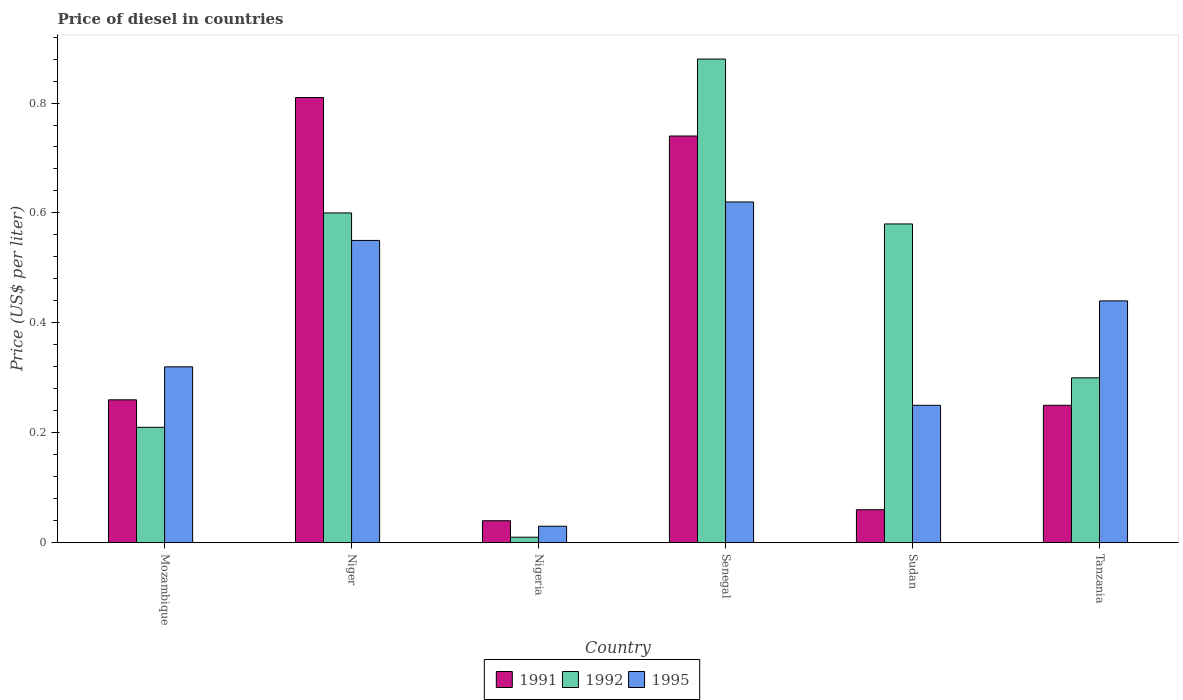How many different coloured bars are there?
Provide a succinct answer. 3. How many groups of bars are there?
Your response must be concise. 6. How many bars are there on the 5th tick from the left?
Make the answer very short. 3. How many bars are there on the 6th tick from the right?
Your answer should be very brief. 3. What is the label of the 6th group of bars from the left?
Your answer should be compact. Tanzania. What is the price of diesel in 1992 in Nigeria?
Provide a short and direct response. 0.01. Across all countries, what is the maximum price of diesel in 1991?
Your answer should be compact. 0.81. In which country was the price of diesel in 1991 maximum?
Ensure brevity in your answer.  Niger. In which country was the price of diesel in 1991 minimum?
Provide a short and direct response. Nigeria. What is the total price of diesel in 1991 in the graph?
Your answer should be very brief. 2.16. What is the difference between the price of diesel in 1992 in Mozambique and that in Niger?
Your response must be concise. -0.39. What is the difference between the price of diesel in 1995 in Tanzania and the price of diesel in 1991 in Sudan?
Offer a very short reply. 0.38. What is the average price of diesel in 1995 per country?
Offer a terse response. 0.37. What is the difference between the price of diesel of/in 1992 and price of diesel of/in 1995 in Niger?
Make the answer very short. 0.05. Is the price of diesel in 1995 in Mozambique less than that in Nigeria?
Your response must be concise. No. What is the difference between the highest and the second highest price of diesel in 1991?
Ensure brevity in your answer.  0.07. What is the difference between the highest and the lowest price of diesel in 1991?
Your response must be concise. 0.77. In how many countries, is the price of diesel in 1995 greater than the average price of diesel in 1995 taken over all countries?
Provide a succinct answer. 3. Is the sum of the price of diesel in 1992 in Mozambique and Senegal greater than the maximum price of diesel in 1991 across all countries?
Your response must be concise. Yes. What does the 1st bar from the left in Sudan represents?
Provide a short and direct response. 1991. How many countries are there in the graph?
Offer a terse response. 6. What is the difference between two consecutive major ticks on the Y-axis?
Keep it short and to the point. 0.2. Does the graph contain any zero values?
Your answer should be compact. No. Does the graph contain grids?
Ensure brevity in your answer.  No. What is the title of the graph?
Provide a short and direct response. Price of diesel in countries. Does "1982" appear as one of the legend labels in the graph?
Give a very brief answer. No. What is the label or title of the Y-axis?
Offer a terse response. Price (US$ per liter). What is the Price (US$ per liter) in 1991 in Mozambique?
Offer a very short reply. 0.26. What is the Price (US$ per liter) of 1992 in Mozambique?
Provide a succinct answer. 0.21. What is the Price (US$ per liter) in 1995 in Mozambique?
Offer a very short reply. 0.32. What is the Price (US$ per liter) of 1991 in Niger?
Your answer should be very brief. 0.81. What is the Price (US$ per liter) of 1995 in Niger?
Provide a succinct answer. 0.55. What is the Price (US$ per liter) of 1991 in Nigeria?
Keep it short and to the point. 0.04. What is the Price (US$ per liter) in 1992 in Nigeria?
Ensure brevity in your answer.  0.01. What is the Price (US$ per liter) in 1995 in Nigeria?
Keep it short and to the point. 0.03. What is the Price (US$ per liter) in 1991 in Senegal?
Make the answer very short. 0.74. What is the Price (US$ per liter) in 1995 in Senegal?
Offer a very short reply. 0.62. What is the Price (US$ per liter) of 1991 in Sudan?
Offer a terse response. 0.06. What is the Price (US$ per liter) of 1992 in Sudan?
Ensure brevity in your answer.  0.58. What is the Price (US$ per liter) in 1995 in Tanzania?
Provide a short and direct response. 0.44. Across all countries, what is the maximum Price (US$ per liter) in 1991?
Offer a terse response. 0.81. Across all countries, what is the maximum Price (US$ per liter) of 1992?
Your response must be concise. 0.88. Across all countries, what is the maximum Price (US$ per liter) of 1995?
Your response must be concise. 0.62. Across all countries, what is the minimum Price (US$ per liter) of 1992?
Provide a succinct answer. 0.01. What is the total Price (US$ per liter) of 1991 in the graph?
Your answer should be very brief. 2.16. What is the total Price (US$ per liter) in 1992 in the graph?
Your answer should be compact. 2.58. What is the total Price (US$ per liter) in 1995 in the graph?
Offer a very short reply. 2.21. What is the difference between the Price (US$ per liter) in 1991 in Mozambique and that in Niger?
Your response must be concise. -0.55. What is the difference between the Price (US$ per liter) in 1992 in Mozambique and that in Niger?
Provide a succinct answer. -0.39. What is the difference between the Price (US$ per liter) in 1995 in Mozambique and that in Niger?
Your answer should be compact. -0.23. What is the difference between the Price (US$ per liter) in 1991 in Mozambique and that in Nigeria?
Provide a short and direct response. 0.22. What is the difference between the Price (US$ per liter) of 1992 in Mozambique and that in Nigeria?
Provide a short and direct response. 0.2. What is the difference between the Price (US$ per liter) in 1995 in Mozambique and that in Nigeria?
Your answer should be very brief. 0.29. What is the difference between the Price (US$ per liter) in 1991 in Mozambique and that in Senegal?
Provide a short and direct response. -0.48. What is the difference between the Price (US$ per liter) of 1992 in Mozambique and that in Senegal?
Ensure brevity in your answer.  -0.67. What is the difference between the Price (US$ per liter) of 1995 in Mozambique and that in Senegal?
Your answer should be compact. -0.3. What is the difference between the Price (US$ per liter) in 1991 in Mozambique and that in Sudan?
Give a very brief answer. 0.2. What is the difference between the Price (US$ per liter) of 1992 in Mozambique and that in Sudan?
Offer a very short reply. -0.37. What is the difference between the Price (US$ per liter) in 1995 in Mozambique and that in Sudan?
Ensure brevity in your answer.  0.07. What is the difference between the Price (US$ per liter) of 1991 in Mozambique and that in Tanzania?
Your answer should be very brief. 0.01. What is the difference between the Price (US$ per liter) of 1992 in Mozambique and that in Tanzania?
Keep it short and to the point. -0.09. What is the difference between the Price (US$ per liter) of 1995 in Mozambique and that in Tanzania?
Your answer should be very brief. -0.12. What is the difference between the Price (US$ per liter) in 1991 in Niger and that in Nigeria?
Offer a terse response. 0.77. What is the difference between the Price (US$ per liter) in 1992 in Niger and that in Nigeria?
Your answer should be very brief. 0.59. What is the difference between the Price (US$ per liter) of 1995 in Niger and that in Nigeria?
Ensure brevity in your answer.  0.52. What is the difference between the Price (US$ per liter) of 1991 in Niger and that in Senegal?
Provide a succinct answer. 0.07. What is the difference between the Price (US$ per liter) in 1992 in Niger and that in Senegal?
Provide a short and direct response. -0.28. What is the difference between the Price (US$ per liter) of 1995 in Niger and that in Senegal?
Ensure brevity in your answer.  -0.07. What is the difference between the Price (US$ per liter) of 1995 in Niger and that in Sudan?
Provide a short and direct response. 0.3. What is the difference between the Price (US$ per liter) of 1991 in Niger and that in Tanzania?
Offer a terse response. 0.56. What is the difference between the Price (US$ per liter) of 1995 in Niger and that in Tanzania?
Give a very brief answer. 0.11. What is the difference between the Price (US$ per liter) of 1992 in Nigeria and that in Senegal?
Provide a succinct answer. -0.87. What is the difference between the Price (US$ per liter) in 1995 in Nigeria and that in Senegal?
Offer a terse response. -0.59. What is the difference between the Price (US$ per liter) in 1991 in Nigeria and that in Sudan?
Give a very brief answer. -0.02. What is the difference between the Price (US$ per liter) in 1992 in Nigeria and that in Sudan?
Keep it short and to the point. -0.57. What is the difference between the Price (US$ per liter) in 1995 in Nigeria and that in Sudan?
Your answer should be very brief. -0.22. What is the difference between the Price (US$ per liter) in 1991 in Nigeria and that in Tanzania?
Your answer should be compact. -0.21. What is the difference between the Price (US$ per liter) in 1992 in Nigeria and that in Tanzania?
Provide a short and direct response. -0.29. What is the difference between the Price (US$ per liter) of 1995 in Nigeria and that in Tanzania?
Your answer should be compact. -0.41. What is the difference between the Price (US$ per liter) of 1991 in Senegal and that in Sudan?
Offer a terse response. 0.68. What is the difference between the Price (US$ per liter) of 1995 in Senegal and that in Sudan?
Provide a short and direct response. 0.37. What is the difference between the Price (US$ per liter) of 1991 in Senegal and that in Tanzania?
Provide a succinct answer. 0.49. What is the difference between the Price (US$ per liter) of 1992 in Senegal and that in Tanzania?
Your response must be concise. 0.58. What is the difference between the Price (US$ per liter) of 1995 in Senegal and that in Tanzania?
Make the answer very short. 0.18. What is the difference between the Price (US$ per liter) of 1991 in Sudan and that in Tanzania?
Give a very brief answer. -0.19. What is the difference between the Price (US$ per liter) in 1992 in Sudan and that in Tanzania?
Your response must be concise. 0.28. What is the difference between the Price (US$ per liter) in 1995 in Sudan and that in Tanzania?
Give a very brief answer. -0.19. What is the difference between the Price (US$ per liter) in 1991 in Mozambique and the Price (US$ per liter) in 1992 in Niger?
Give a very brief answer. -0.34. What is the difference between the Price (US$ per liter) in 1991 in Mozambique and the Price (US$ per liter) in 1995 in Niger?
Make the answer very short. -0.29. What is the difference between the Price (US$ per liter) in 1992 in Mozambique and the Price (US$ per liter) in 1995 in Niger?
Offer a terse response. -0.34. What is the difference between the Price (US$ per liter) in 1991 in Mozambique and the Price (US$ per liter) in 1992 in Nigeria?
Your answer should be very brief. 0.25. What is the difference between the Price (US$ per liter) of 1991 in Mozambique and the Price (US$ per liter) of 1995 in Nigeria?
Your answer should be very brief. 0.23. What is the difference between the Price (US$ per liter) in 1992 in Mozambique and the Price (US$ per liter) in 1995 in Nigeria?
Give a very brief answer. 0.18. What is the difference between the Price (US$ per liter) of 1991 in Mozambique and the Price (US$ per liter) of 1992 in Senegal?
Your response must be concise. -0.62. What is the difference between the Price (US$ per liter) of 1991 in Mozambique and the Price (US$ per liter) of 1995 in Senegal?
Offer a terse response. -0.36. What is the difference between the Price (US$ per liter) of 1992 in Mozambique and the Price (US$ per liter) of 1995 in Senegal?
Keep it short and to the point. -0.41. What is the difference between the Price (US$ per liter) of 1991 in Mozambique and the Price (US$ per liter) of 1992 in Sudan?
Ensure brevity in your answer.  -0.32. What is the difference between the Price (US$ per liter) in 1991 in Mozambique and the Price (US$ per liter) in 1995 in Sudan?
Offer a terse response. 0.01. What is the difference between the Price (US$ per liter) in 1992 in Mozambique and the Price (US$ per liter) in 1995 in Sudan?
Make the answer very short. -0.04. What is the difference between the Price (US$ per liter) in 1991 in Mozambique and the Price (US$ per liter) in 1992 in Tanzania?
Make the answer very short. -0.04. What is the difference between the Price (US$ per liter) of 1991 in Mozambique and the Price (US$ per liter) of 1995 in Tanzania?
Offer a terse response. -0.18. What is the difference between the Price (US$ per liter) of 1992 in Mozambique and the Price (US$ per liter) of 1995 in Tanzania?
Make the answer very short. -0.23. What is the difference between the Price (US$ per liter) in 1991 in Niger and the Price (US$ per liter) in 1995 in Nigeria?
Give a very brief answer. 0.78. What is the difference between the Price (US$ per liter) of 1992 in Niger and the Price (US$ per liter) of 1995 in Nigeria?
Keep it short and to the point. 0.57. What is the difference between the Price (US$ per liter) in 1991 in Niger and the Price (US$ per liter) in 1992 in Senegal?
Your answer should be compact. -0.07. What is the difference between the Price (US$ per liter) of 1991 in Niger and the Price (US$ per liter) of 1995 in Senegal?
Your answer should be very brief. 0.19. What is the difference between the Price (US$ per liter) in 1992 in Niger and the Price (US$ per liter) in 1995 in Senegal?
Offer a very short reply. -0.02. What is the difference between the Price (US$ per liter) in 1991 in Niger and the Price (US$ per liter) in 1992 in Sudan?
Offer a terse response. 0.23. What is the difference between the Price (US$ per liter) of 1991 in Niger and the Price (US$ per liter) of 1995 in Sudan?
Offer a terse response. 0.56. What is the difference between the Price (US$ per liter) of 1991 in Niger and the Price (US$ per liter) of 1992 in Tanzania?
Your response must be concise. 0.51. What is the difference between the Price (US$ per liter) in 1991 in Niger and the Price (US$ per liter) in 1995 in Tanzania?
Keep it short and to the point. 0.37. What is the difference between the Price (US$ per liter) in 1992 in Niger and the Price (US$ per liter) in 1995 in Tanzania?
Ensure brevity in your answer.  0.16. What is the difference between the Price (US$ per liter) in 1991 in Nigeria and the Price (US$ per liter) in 1992 in Senegal?
Your answer should be compact. -0.84. What is the difference between the Price (US$ per liter) in 1991 in Nigeria and the Price (US$ per liter) in 1995 in Senegal?
Offer a terse response. -0.58. What is the difference between the Price (US$ per liter) of 1992 in Nigeria and the Price (US$ per liter) of 1995 in Senegal?
Your response must be concise. -0.61. What is the difference between the Price (US$ per liter) in 1991 in Nigeria and the Price (US$ per liter) in 1992 in Sudan?
Offer a very short reply. -0.54. What is the difference between the Price (US$ per liter) of 1991 in Nigeria and the Price (US$ per liter) of 1995 in Sudan?
Offer a very short reply. -0.21. What is the difference between the Price (US$ per liter) in 1992 in Nigeria and the Price (US$ per liter) in 1995 in Sudan?
Provide a succinct answer. -0.24. What is the difference between the Price (US$ per liter) in 1991 in Nigeria and the Price (US$ per liter) in 1992 in Tanzania?
Ensure brevity in your answer.  -0.26. What is the difference between the Price (US$ per liter) of 1991 in Nigeria and the Price (US$ per liter) of 1995 in Tanzania?
Your answer should be compact. -0.4. What is the difference between the Price (US$ per liter) of 1992 in Nigeria and the Price (US$ per liter) of 1995 in Tanzania?
Your answer should be compact. -0.43. What is the difference between the Price (US$ per liter) of 1991 in Senegal and the Price (US$ per liter) of 1992 in Sudan?
Make the answer very short. 0.16. What is the difference between the Price (US$ per liter) of 1991 in Senegal and the Price (US$ per liter) of 1995 in Sudan?
Offer a very short reply. 0.49. What is the difference between the Price (US$ per liter) of 1992 in Senegal and the Price (US$ per liter) of 1995 in Sudan?
Your answer should be compact. 0.63. What is the difference between the Price (US$ per liter) in 1991 in Senegal and the Price (US$ per liter) in 1992 in Tanzania?
Keep it short and to the point. 0.44. What is the difference between the Price (US$ per liter) in 1991 in Senegal and the Price (US$ per liter) in 1995 in Tanzania?
Your answer should be compact. 0.3. What is the difference between the Price (US$ per liter) of 1992 in Senegal and the Price (US$ per liter) of 1995 in Tanzania?
Your answer should be compact. 0.44. What is the difference between the Price (US$ per liter) in 1991 in Sudan and the Price (US$ per liter) in 1992 in Tanzania?
Offer a very short reply. -0.24. What is the difference between the Price (US$ per liter) in 1991 in Sudan and the Price (US$ per liter) in 1995 in Tanzania?
Your answer should be compact. -0.38. What is the difference between the Price (US$ per liter) in 1992 in Sudan and the Price (US$ per liter) in 1995 in Tanzania?
Offer a very short reply. 0.14. What is the average Price (US$ per liter) of 1991 per country?
Keep it short and to the point. 0.36. What is the average Price (US$ per liter) of 1992 per country?
Provide a short and direct response. 0.43. What is the average Price (US$ per liter) of 1995 per country?
Make the answer very short. 0.37. What is the difference between the Price (US$ per liter) of 1991 and Price (US$ per liter) of 1992 in Mozambique?
Your answer should be very brief. 0.05. What is the difference between the Price (US$ per liter) in 1991 and Price (US$ per liter) in 1995 in Mozambique?
Offer a very short reply. -0.06. What is the difference between the Price (US$ per liter) of 1992 and Price (US$ per liter) of 1995 in Mozambique?
Keep it short and to the point. -0.11. What is the difference between the Price (US$ per liter) in 1991 and Price (US$ per liter) in 1992 in Niger?
Give a very brief answer. 0.21. What is the difference between the Price (US$ per liter) in 1991 and Price (US$ per liter) in 1995 in Niger?
Give a very brief answer. 0.26. What is the difference between the Price (US$ per liter) of 1992 and Price (US$ per liter) of 1995 in Niger?
Your answer should be very brief. 0.05. What is the difference between the Price (US$ per liter) in 1991 and Price (US$ per liter) in 1992 in Nigeria?
Make the answer very short. 0.03. What is the difference between the Price (US$ per liter) in 1991 and Price (US$ per liter) in 1995 in Nigeria?
Keep it short and to the point. 0.01. What is the difference between the Price (US$ per liter) in 1992 and Price (US$ per liter) in 1995 in Nigeria?
Keep it short and to the point. -0.02. What is the difference between the Price (US$ per liter) in 1991 and Price (US$ per liter) in 1992 in Senegal?
Provide a succinct answer. -0.14. What is the difference between the Price (US$ per liter) in 1991 and Price (US$ per liter) in 1995 in Senegal?
Keep it short and to the point. 0.12. What is the difference between the Price (US$ per liter) in 1992 and Price (US$ per liter) in 1995 in Senegal?
Keep it short and to the point. 0.26. What is the difference between the Price (US$ per liter) in 1991 and Price (US$ per liter) in 1992 in Sudan?
Offer a terse response. -0.52. What is the difference between the Price (US$ per liter) in 1991 and Price (US$ per liter) in 1995 in Sudan?
Offer a terse response. -0.19. What is the difference between the Price (US$ per liter) of 1992 and Price (US$ per liter) of 1995 in Sudan?
Keep it short and to the point. 0.33. What is the difference between the Price (US$ per liter) in 1991 and Price (US$ per liter) in 1992 in Tanzania?
Keep it short and to the point. -0.05. What is the difference between the Price (US$ per liter) in 1991 and Price (US$ per liter) in 1995 in Tanzania?
Provide a succinct answer. -0.19. What is the difference between the Price (US$ per liter) in 1992 and Price (US$ per liter) in 1995 in Tanzania?
Offer a very short reply. -0.14. What is the ratio of the Price (US$ per liter) in 1991 in Mozambique to that in Niger?
Keep it short and to the point. 0.32. What is the ratio of the Price (US$ per liter) of 1992 in Mozambique to that in Niger?
Offer a terse response. 0.35. What is the ratio of the Price (US$ per liter) of 1995 in Mozambique to that in Niger?
Your response must be concise. 0.58. What is the ratio of the Price (US$ per liter) of 1992 in Mozambique to that in Nigeria?
Provide a short and direct response. 21. What is the ratio of the Price (US$ per liter) in 1995 in Mozambique to that in Nigeria?
Keep it short and to the point. 10.67. What is the ratio of the Price (US$ per liter) in 1991 in Mozambique to that in Senegal?
Keep it short and to the point. 0.35. What is the ratio of the Price (US$ per liter) of 1992 in Mozambique to that in Senegal?
Give a very brief answer. 0.24. What is the ratio of the Price (US$ per liter) in 1995 in Mozambique to that in Senegal?
Your response must be concise. 0.52. What is the ratio of the Price (US$ per liter) in 1991 in Mozambique to that in Sudan?
Make the answer very short. 4.33. What is the ratio of the Price (US$ per liter) in 1992 in Mozambique to that in Sudan?
Offer a terse response. 0.36. What is the ratio of the Price (US$ per liter) of 1995 in Mozambique to that in Sudan?
Give a very brief answer. 1.28. What is the ratio of the Price (US$ per liter) in 1992 in Mozambique to that in Tanzania?
Make the answer very short. 0.7. What is the ratio of the Price (US$ per liter) of 1995 in Mozambique to that in Tanzania?
Keep it short and to the point. 0.73. What is the ratio of the Price (US$ per liter) of 1991 in Niger to that in Nigeria?
Your answer should be compact. 20.25. What is the ratio of the Price (US$ per liter) of 1992 in Niger to that in Nigeria?
Your answer should be compact. 60. What is the ratio of the Price (US$ per liter) in 1995 in Niger to that in Nigeria?
Your answer should be very brief. 18.33. What is the ratio of the Price (US$ per liter) in 1991 in Niger to that in Senegal?
Offer a terse response. 1.09. What is the ratio of the Price (US$ per liter) of 1992 in Niger to that in Senegal?
Your answer should be compact. 0.68. What is the ratio of the Price (US$ per liter) of 1995 in Niger to that in Senegal?
Ensure brevity in your answer.  0.89. What is the ratio of the Price (US$ per liter) of 1991 in Niger to that in Sudan?
Ensure brevity in your answer.  13.5. What is the ratio of the Price (US$ per liter) of 1992 in Niger to that in Sudan?
Make the answer very short. 1.03. What is the ratio of the Price (US$ per liter) of 1991 in Niger to that in Tanzania?
Offer a very short reply. 3.24. What is the ratio of the Price (US$ per liter) of 1995 in Niger to that in Tanzania?
Ensure brevity in your answer.  1.25. What is the ratio of the Price (US$ per liter) of 1991 in Nigeria to that in Senegal?
Offer a very short reply. 0.05. What is the ratio of the Price (US$ per liter) of 1992 in Nigeria to that in Senegal?
Provide a short and direct response. 0.01. What is the ratio of the Price (US$ per liter) of 1995 in Nigeria to that in Senegal?
Provide a succinct answer. 0.05. What is the ratio of the Price (US$ per liter) in 1992 in Nigeria to that in Sudan?
Provide a short and direct response. 0.02. What is the ratio of the Price (US$ per liter) in 1995 in Nigeria to that in Sudan?
Offer a terse response. 0.12. What is the ratio of the Price (US$ per liter) in 1991 in Nigeria to that in Tanzania?
Your answer should be very brief. 0.16. What is the ratio of the Price (US$ per liter) in 1992 in Nigeria to that in Tanzania?
Your answer should be compact. 0.03. What is the ratio of the Price (US$ per liter) of 1995 in Nigeria to that in Tanzania?
Your response must be concise. 0.07. What is the ratio of the Price (US$ per liter) in 1991 in Senegal to that in Sudan?
Offer a very short reply. 12.33. What is the ratio of the Price (US$ per liter) of 1992 in Senegal to that in Sudan?
Provide a short and direct response. 1.52. What is the ratio of the Price (US$ per liter) of 1995 in Senegal to that in Sudan?
Provide a succinct answer. 2.48. What is the ratio of the Price (US$ per liter) of 1991 in Senegal to that in Tanzania?
Your answer should be very brief. 2.96. What is the ratio of the Price (US$ per liter) in 1992 in Senegal to that in Tanzania?
Provide a succinct answer. 2.93. What is the ratio of the Price (US$ per liter) in 1995 in Senegal to that in Tanzania?
Ensure brevity in your answer.  1.41. What is the ratio of the Price (US$ per liter) in 1991 in Sudan to that in Tanzania?
Keep it short and to the point. 0.24. What is the ratio of the Price (US$ per liter) of 1992 in Sudan to that in Tanzania?
Provide a short and direct response. 1.93. What is the ratio of the Price (US$ per liter) in 1995 in Sudan to that in Tanzania?
Your answer should be compact. 0.57. What is the difference between the highest and the second highest Price (US$ per liter) of 1991?
Offer a very short reply. 0.07. What is the difference between the highest and the second highest Price (US$ per liter) in 1992?
Offer a very short reply. 0.28. What is the difference between the highest and the second highest Price (US$ per liter) of 1995?
Offer a very short reply. 0.07. What is the difference between the highest and the lowest Price (US$ per liter) in 1991?
Offer a very short reply. 0.77. What is the difference between the highest and the lowest Price (US$ per liter) in 1992?
Keep it short and to the point. 0.87. What is the difference between the highest and the lowest Price (US$ per liter) of 1995?
Offer a very short reply. 0.59. 